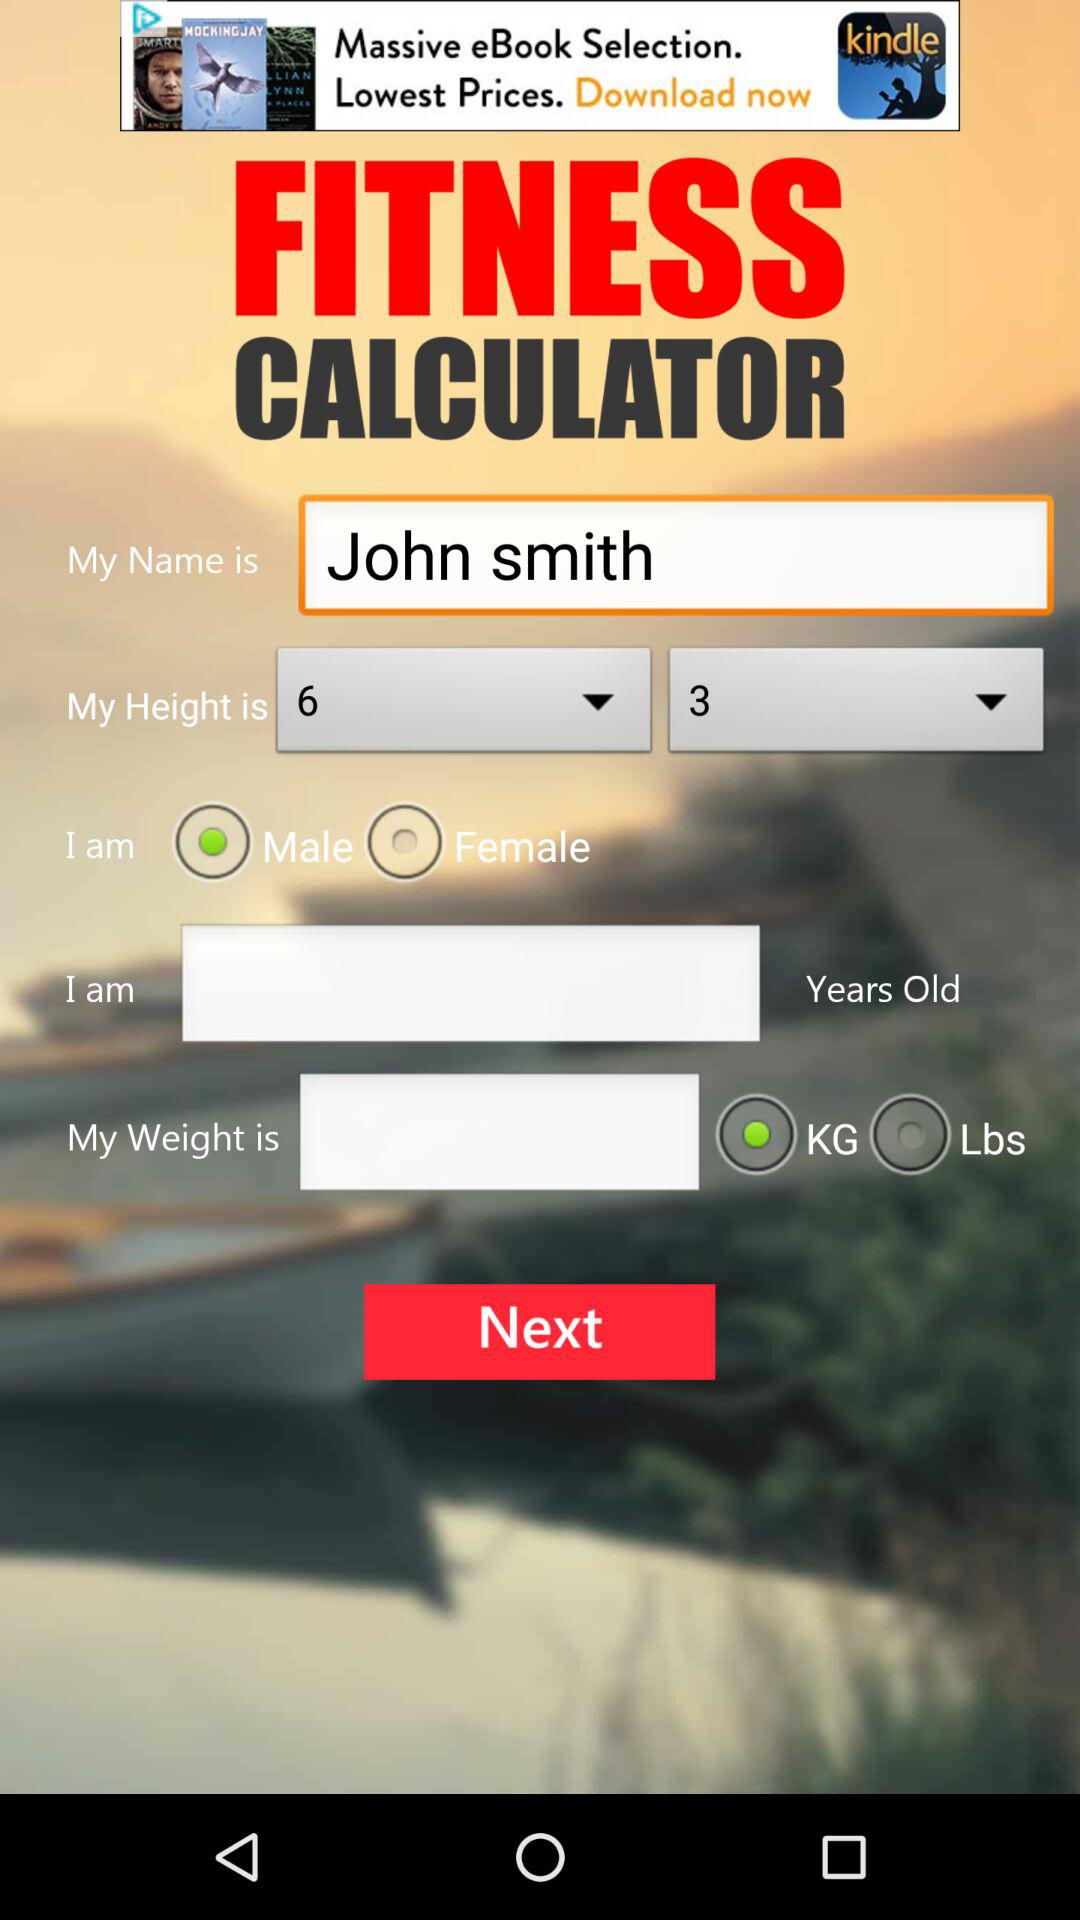How old is John Smith?
When the provided information is insufficient, respond with <no answer>. <no answer> 